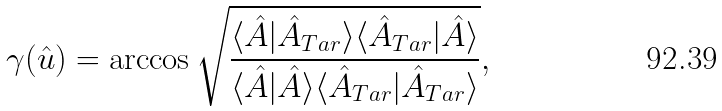<formula> <loc_0><loc_0><loc_500><loc_500>\gamma ( \hat { u } ) = \arccos \sqrt { \frac { \langle \hat { A } | \hat { A } _ { T a r } \rangle \langle \hat { A } _ { T a r } | \hat { A } \rangle } { \langle \hat { A } | \hat { A } \rangle \langle \hat { A } _ { T a r } | \hat { A } _ { T a r } \rangle } } ,</formula> 